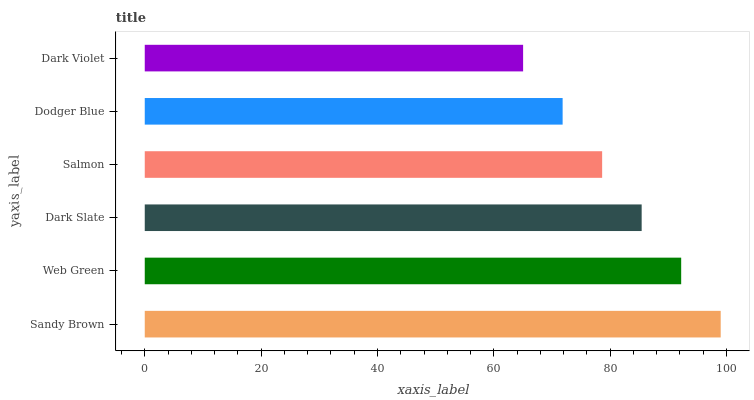Is Dark Violet the minimum?
Answer yes or no. Yes. Is Sandy Brown the maximum?
Answer yes or no. Yes. Is Web Green the minimum?
Answer yes or no. No. Is Web Green the maximum?
Answer yes or no. No. Is Sandy Brown greater than Web Green?
Answer yes or no. Yes. Is Web Green less than Sandy Brown?
Answer yes or no. Yes. Is Web Green greater than Sandy Brown?
Answer yes or no. No. Is Sandy Brown less than Web Green?
Answer yes or no. No. Is Dark Slate the high median?
Answer yes or no. Yes. Is Salmon the low median?
Answer yes or no. Yes. Is Dark Violet the high median?
Answer yes or no. No. Is Dark Violet the low median?
Answer yes or no. No. 